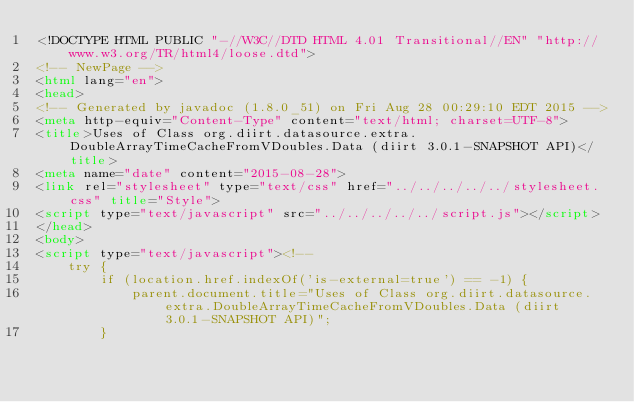<code> <loc_0><loc_0><loc_500><loc_500><_HTML_><!DOCTYPE HTML PUBLIC "-//W3C//DTD HTML 4.01 Transitional//EN" "http://www.w3.org/TR/html4/loose.dtd">
<!-- NewPage -->
<html lang="en">
<head>
<!-- Generated by javadoc (1.8.0_51) on Fri Aug 28 00:29:10 EDT 2015 -->
<meta http-equiv="Content-Type" content="text/html; charset=UTF-8">
<title>Uses of Class org.diirt.datasource.extra.DoubleArrayTimeCacheFromVDoubles.Data (diirt 3.0.1-SNAPSHOT API)</title>
<meta name="date" content="2015-08-28">
<link rel="stylesheet" type="text/css" href="../../../../../stylesheet.css" title="Style">
<script type="text/javascript" src="../../../../../script.js"></script>
</head>
<body>
<script type="text/javascript"><!--
    try {
        if (location.href.indexOf('is-external=true') == -1) {
            parent.document.title="Uses of Class org.diirt.datasource.extra.DoubleArrayTimeCacheFromVDoubles.Data (diirt 3.0.1-SNAPSHOT API)";
        }</code> 